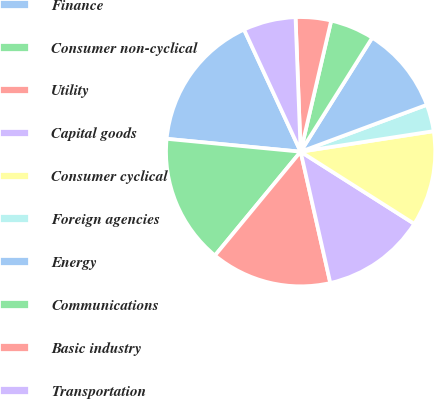Convert chart to OTSL. <chart><loc_0><loc_0><loc_500><loc_500><pie_chart><fcel>Finance<fcel>Consumer non-cyclical<fcel>Utility<fcel>Capital goods<fcel>Consumer cyclical<fcel>Foreign agencies<fcel>Energy<fcel>Communications<fcel>Basic industry<fcel>Transportation<nl><fcel>16.57%<fcel>15.54%<fcel>14.52%<fcel>12.46%<fcel>11.44%<fcel>3.22%<fcel>10.41%<fcel>5.28%<fcel>4.25%<fcel>6.3%<nl></chart> 